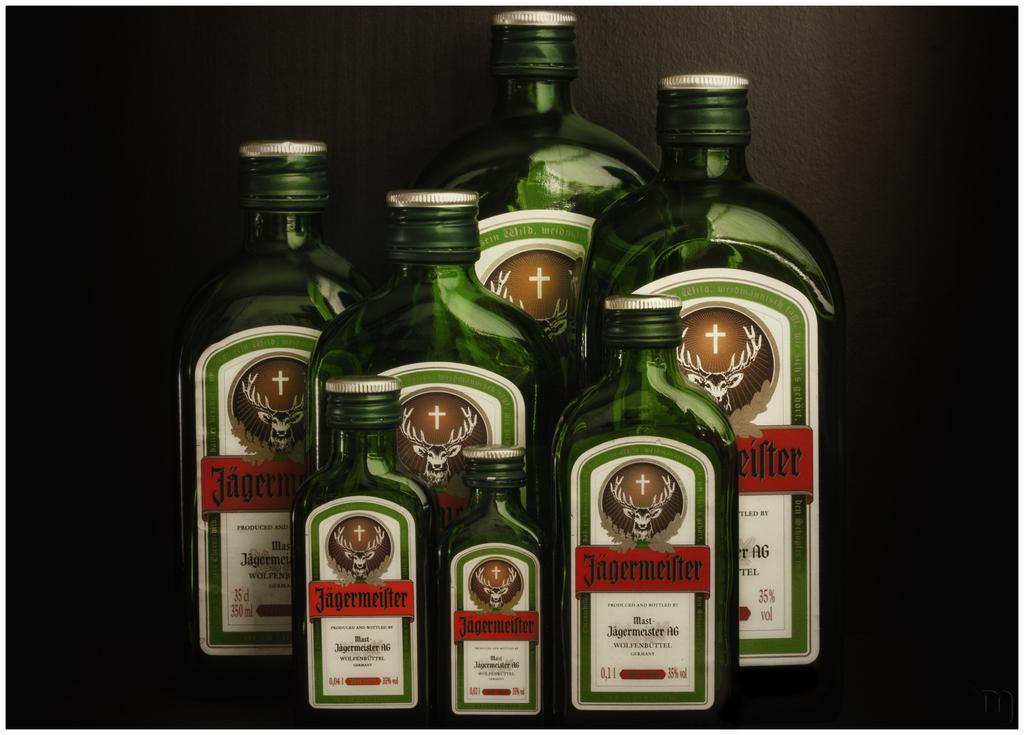<image>
Render a clear and concise summary of the photo. seven bottles that are all labeled as jagermeister 